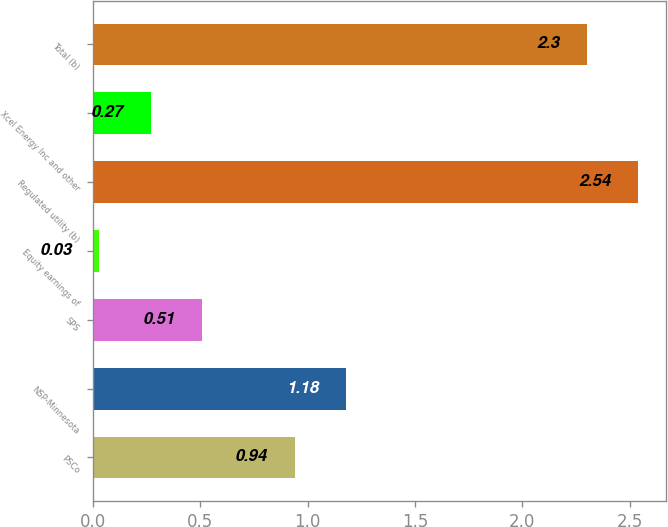Convert chart to OTSL. <chart><loc_0><loc_0><loc_500><loc_500><bar_chart><fcel>PSCo<fcel>NSP-Minnesota<fcel>SPS<fcel>Equity earnings of<fcel>Regulated utility (b)<fcel>Xcel Energy Inc and other<fcel>Total (b)<nl><fcel>0.94<fcel>1.18<fcel>0.51<fcel>0.03<fcel>2.54<fcel>0.27<fcel>2.3<nl></chart> 